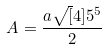<formula> <loc_0><loc_0><loc_500><loc_500>A = \frac { a \sqrt { [ } 4 ] { 5 ^ { 5 } } } { 2 }</formula> 